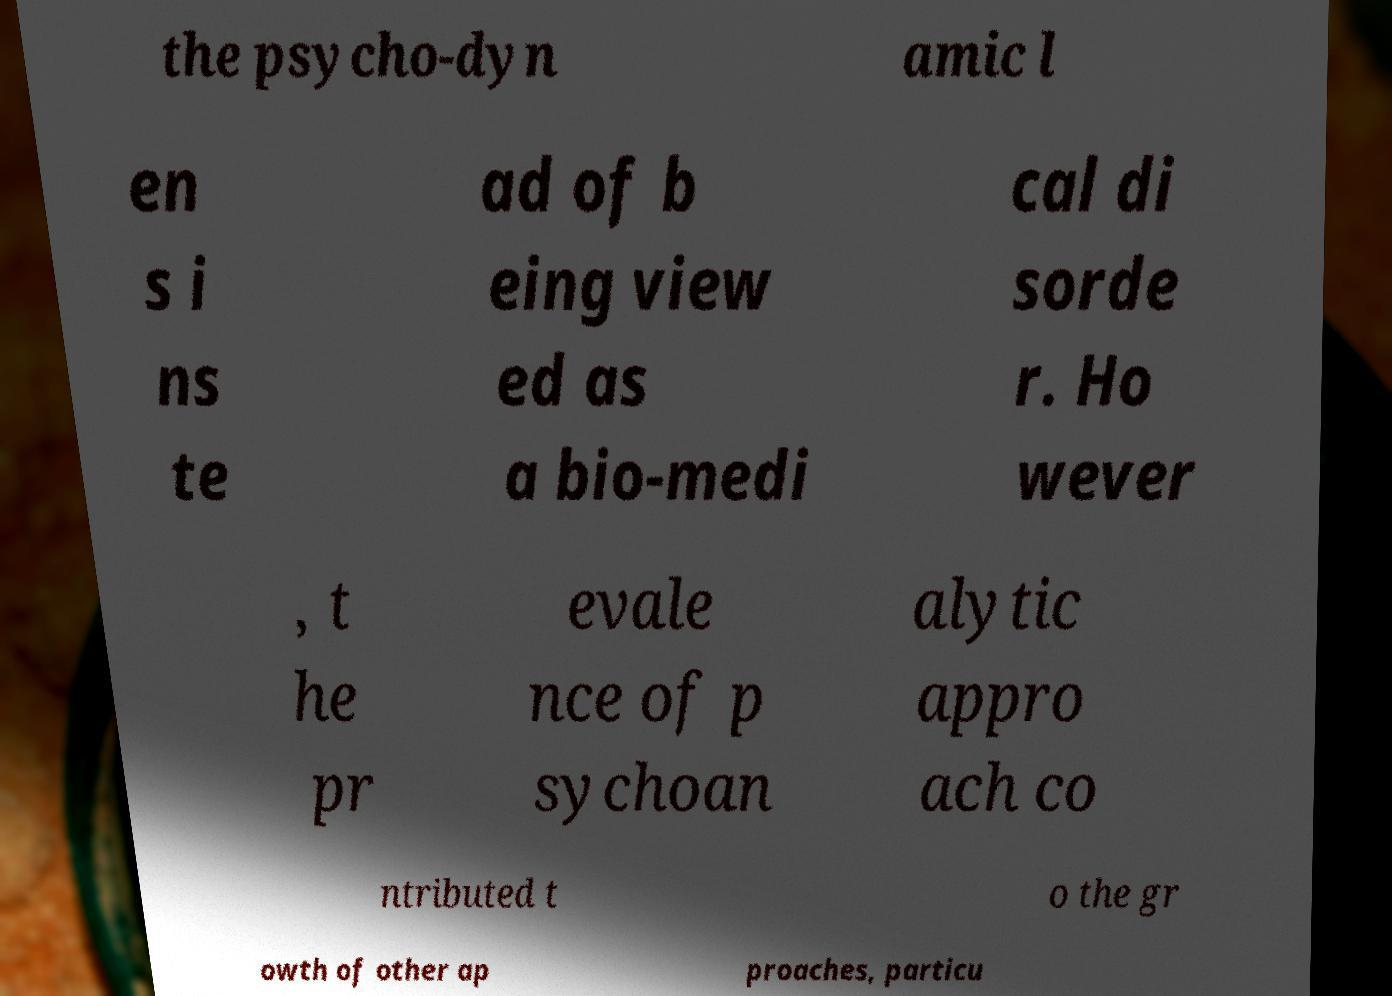What messages or text are displayed in this image? I need them in a readable, typed format. the psycho-dyn amic l en s i ns te ad of b eing view ed as a bio-medi cal di sorde r. Ho wever , t he pr evale nce of p sychoan alytic appro ach co ntributed t o the gr owth of other ap proaches, particu 